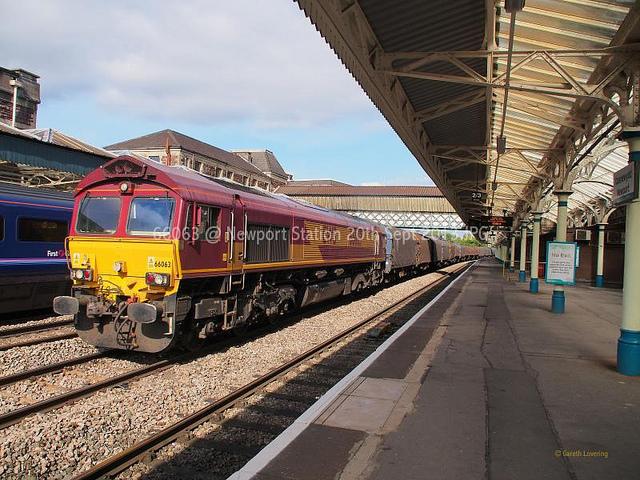Is the platform empty?
Keep it brief. Yes. Where was this taken?
Be succinct. Train station. What are the two colors of the train?
Be succinct. Red and yellow. 